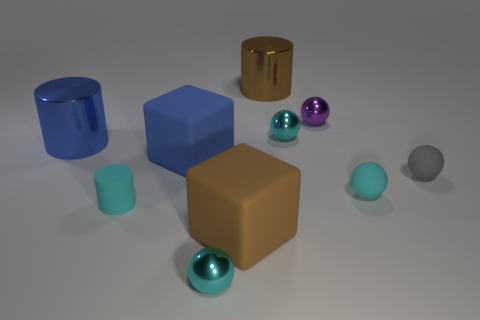How does the lighting in the image affect the appearance of the objects? The lighting in the image creates soft shadows and subtle reflections on the objects, which enhance their three-dimensionality and texture, giving the scene a realistic and slightly dramatic look. 